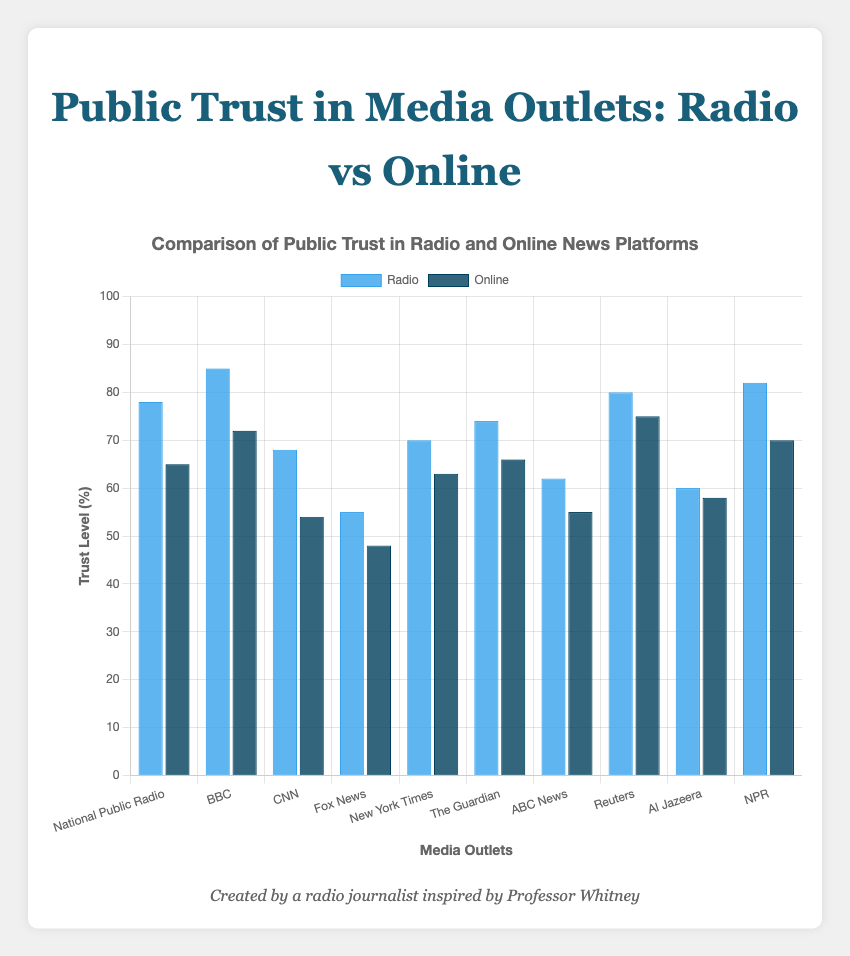What's the overall difference in trust levels between Radio and Online news platforms for the New York Times? The trust level for the New York Times in Radio is 70 and in Online is 63. The difference is 70 - 63 = 7.
Answer: 7 Which media outlet has the highest trust level in both Radio and Online platforms combined? The BBC has trust levels of 85 (Radio) and 72 (Online). Combining them gives 85 + 72 = 157, which is the highest among all outlets.
Answer: BBC Is the trust level in Online platforms ever higher than in Radio? If so, for which outlets? By reviewing all the entries, for each outlet, the trust level in Radio is always higher than or equal to the trust level in Online. So, no outlet has a higher trust level in Online than in Radio.
Answer: No Compare the trust level of NPR across its two forms (Radio versus Online). NPR has a trust level of 82 for Radio and 70 for Online. Thus, in Radio, NPR scores 12 points higher than in Online.
Answer: 12 points higher Which outlet has the smallest difference in trust levels between Radio and Online platforms? Reuters has a trust level of 80 in Radio and 75 in Online, with a difference of 80 - 75 = 5, which is the smallest difference among the outlets.
Answer: Reuters Calculate the average trust level for all Radio platforms displayed in the chart. Add all Radio trust levels and divide by the number of entries: (78 + 85 + 68 + 55 + 70 + 74 + 62 + 80 + 60 + 82) / 10 = 714 / 10.
Answer: 71.4 Which media outlet shows the biggest drop-off in trust when moving from Radio to Online? Comparing the differences, the CNN outlet has the largest drop from Radio (68) to Online (54), with a drop-off of 68 - 54 = 14.
Answer: CNN Are the trust levels for Online platforms for NPR and National Public Radio identical? Reviewing the trust levels, NPR has 70 for Online, while National Public Radio has 65 for Online, so they are not identical.
Answer: No Which media outlet shows almost equal trust levels between Radio and Online platforms? Al Jazeera has a trust level of 60 for Radio and 58 for Online. The difference is 60 - 58 = 2, indicating nearly equal trust levels.
Answer: Al Jazeera What’s the combined average trust level of ABC News and Fox News for both Radio and Online platforms? Trust levels are ABC News: (62 + 55) and Fox News: (55 + 48) respectively. Summing them gives 62+55+55+48 = 220. The average is 220 / 4.
Answer: 55 